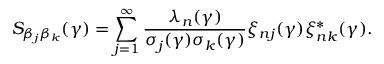<formula> <loc_0><loc_0><loc_500><loc_500>S _ { \beta _ { j } \beta _ { k } } ( \gamma ) = \sum _ { j = 1 } ^ { \infty } \frac { \lambda _ { n } ( \gamma ) } { \sigma _ { j } ( \gamma ) \sigma _ { k } ( \gamma ) } \xi _ { n j } ( \gamma ) \xi _ { n k } ^ { * } ( \gamma ) .</formula> 